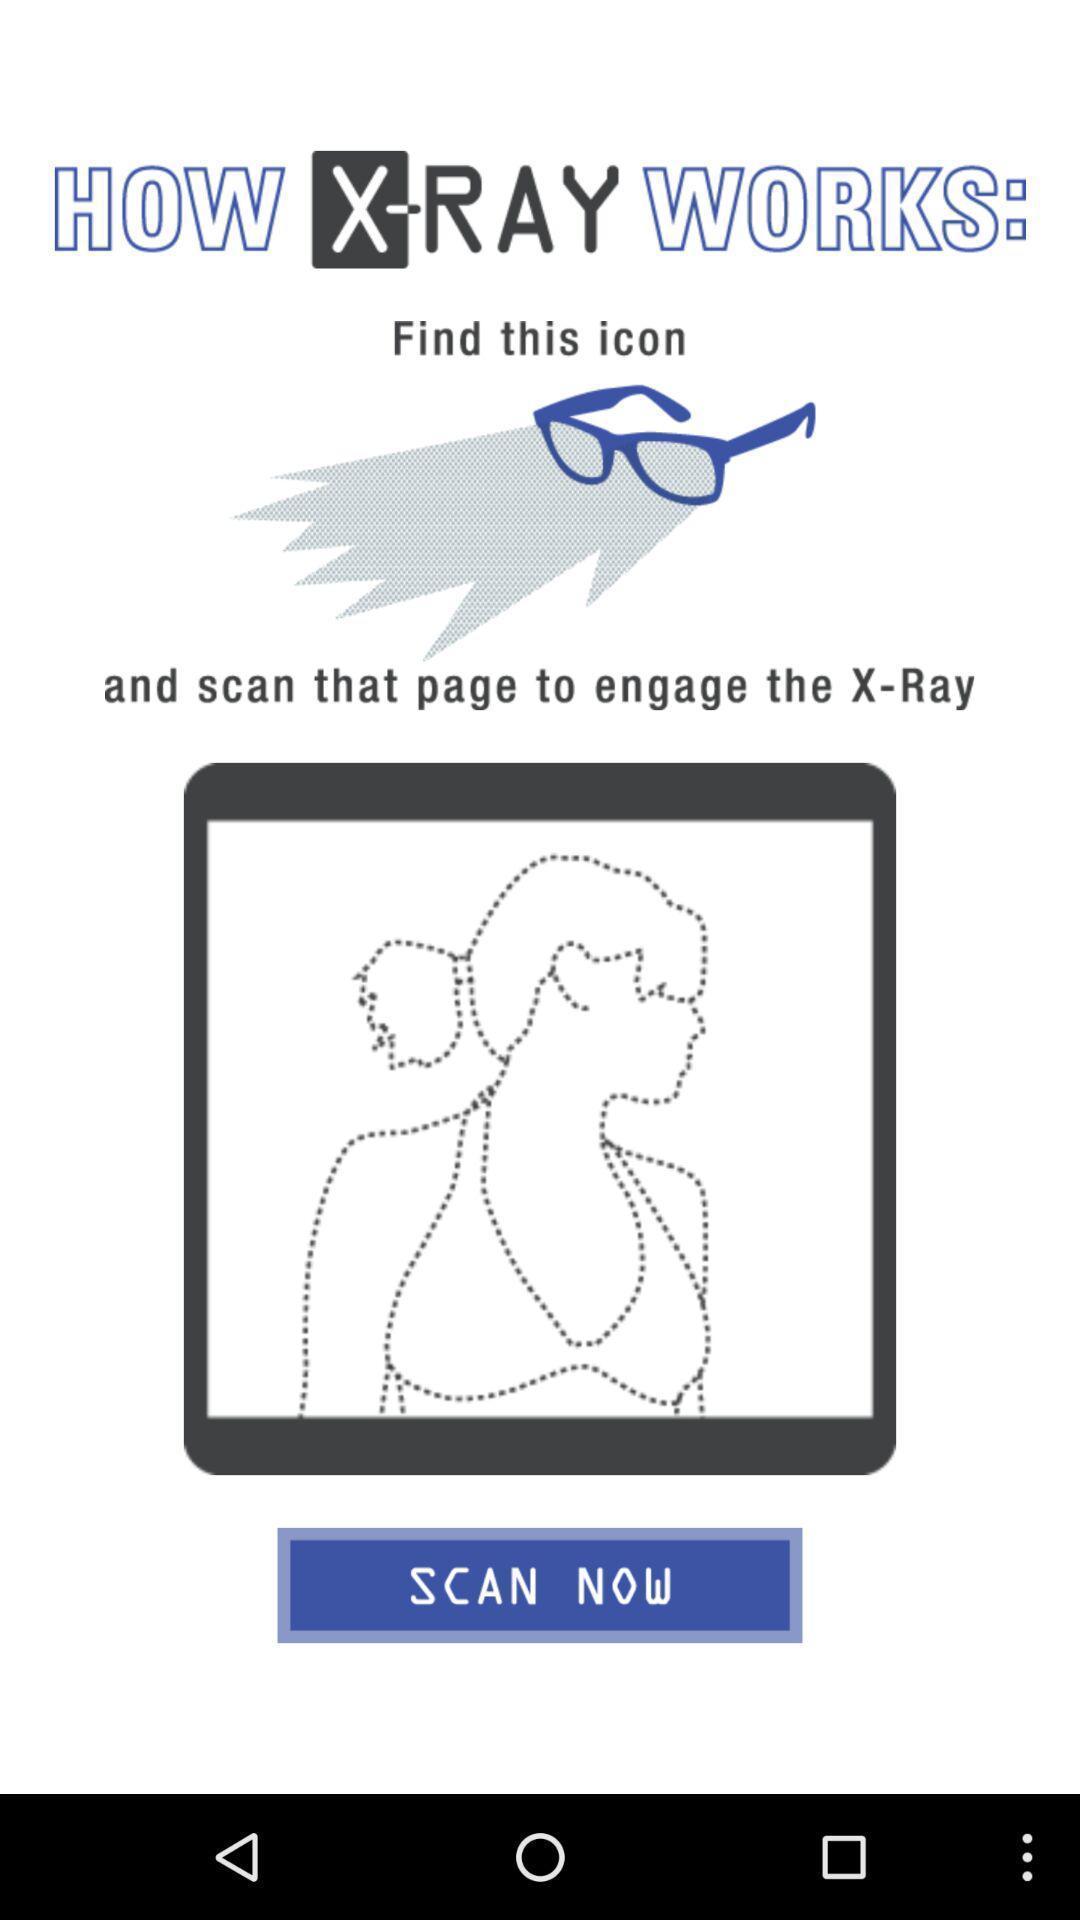Give me a summary of this screen capture. Welcome page. 